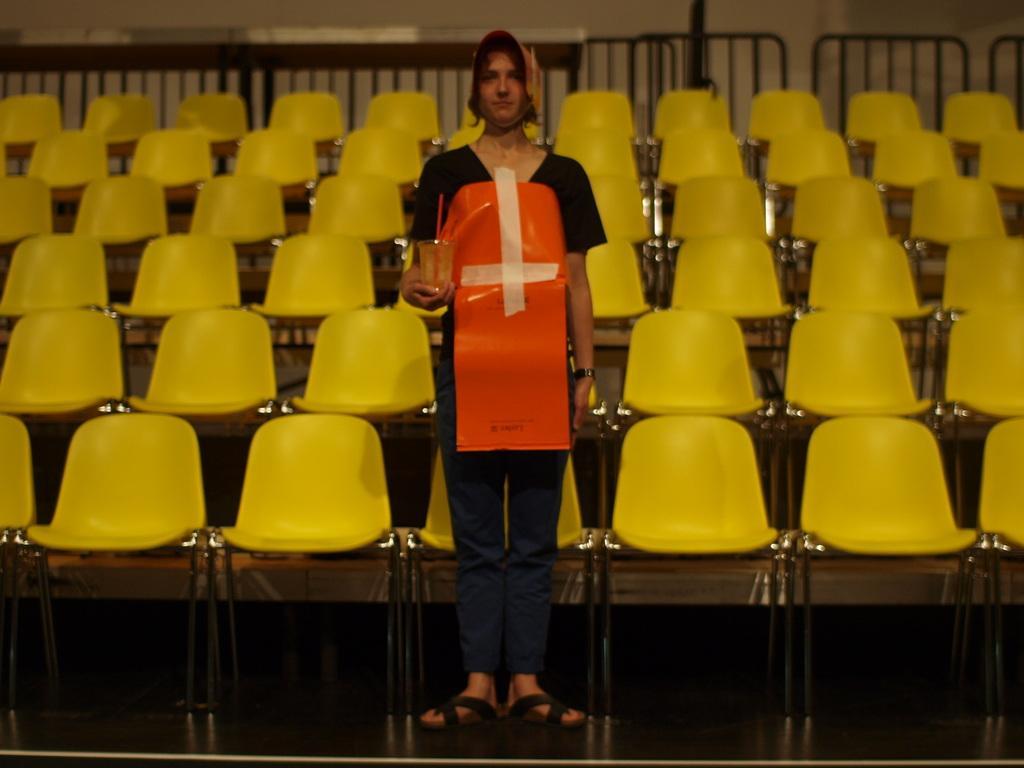In one or two sentences, can you explain what this image depicts? In the middle of the image a person is standing and holding a glass. Behind the person there are some chairs and fencing. Behind the fencing there is wall. 